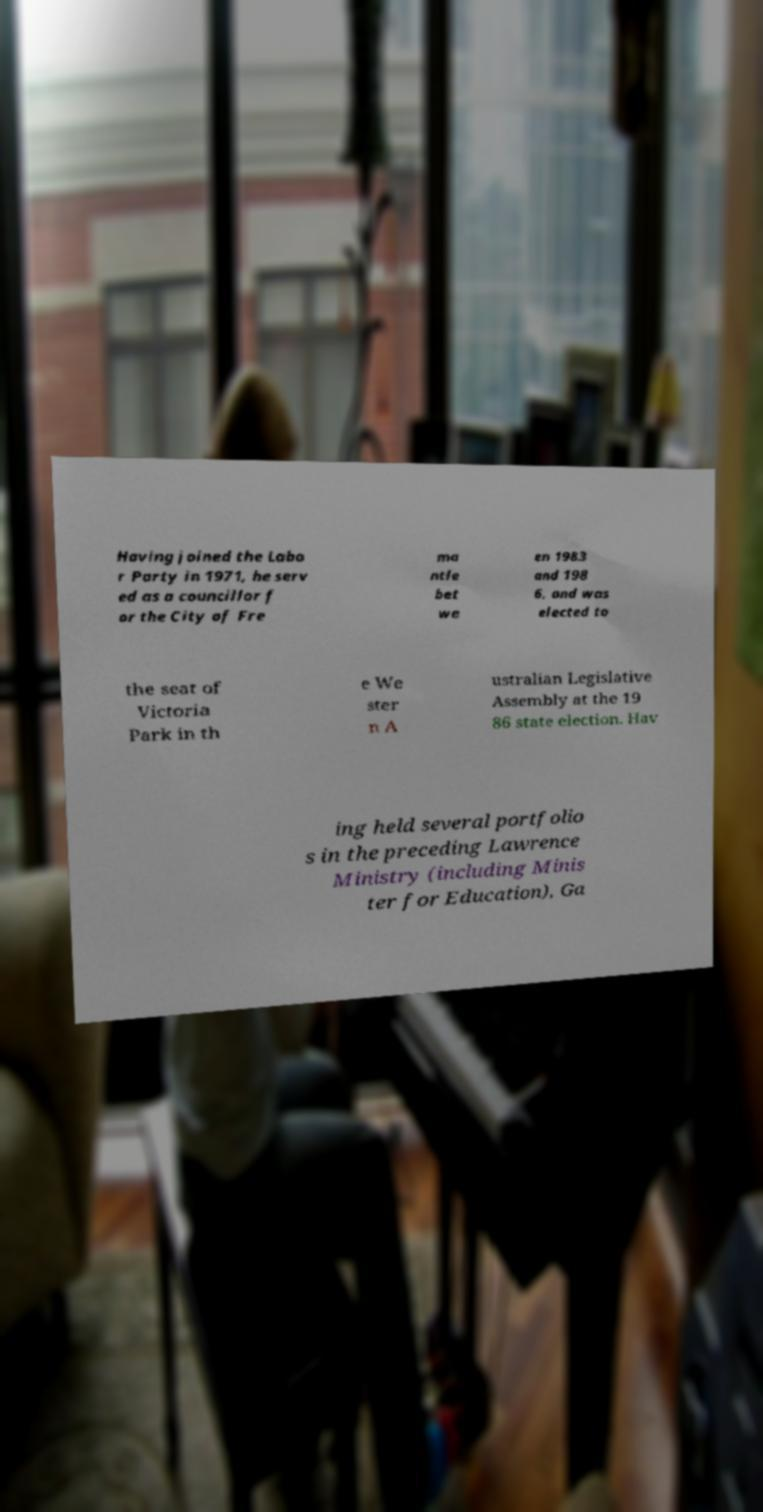Please read and relay the text visible in this image. What does it say? Having joined the Labo r Party in 1971, he serv ed as a councillor f or the City of Fre ma ntle bet we en 1983 and 198 6, and was elected to the seat of Victoria Park in th e We ster n A ustralian Legislative Assembly at the 19 86 state election. Hav ing held several portfolio s in the preceding Lawrence Ministry (including Minis ter for Education), Ga 